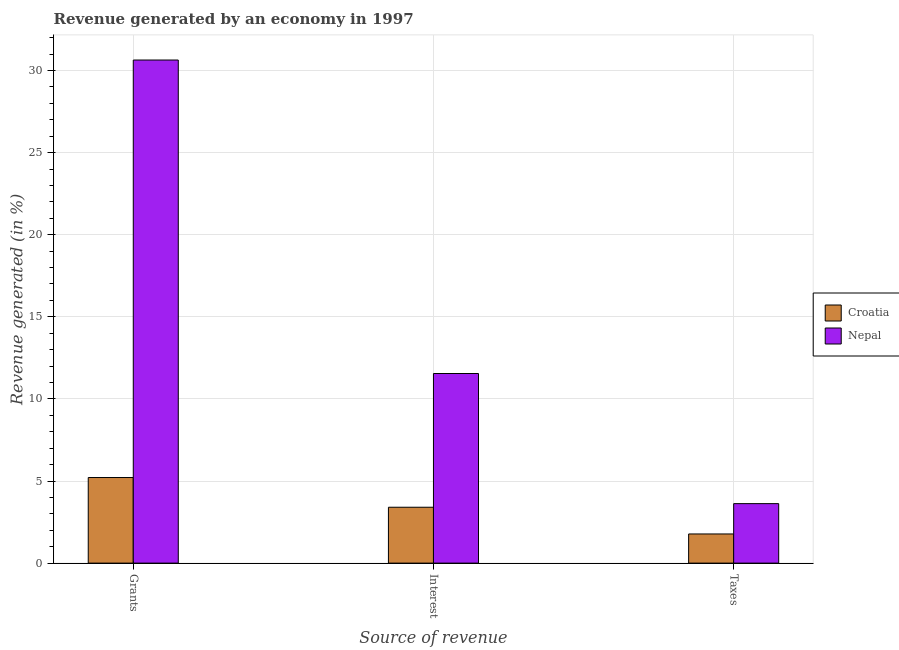How many different coloured bars are there?
Your answer should be very brief. 2. Are the number of bars per tick equal to the number of legend labels?
Ensure brevity in your answer.  Yes. How many bars are there on the 2nd tick from the left?
Provide a short and direct response. 2. How many bars are there on the 2nd tick from the right?
Provide a succinct answer. 2. What is the label of the 1st group of bars from the left?
Make the answer very short. Grants. What is the percentage of revenue generated by interest in Croatia?
Ensure brevity in your answer.  3.4. Across all countries, what is the maximum percentage of revenue generated by taxes?
Make the answer very short. 3.62. Across all countries, what is the minimum percentage of revenue generated by interest?
Offer a very short reply. 3.4. In which country was the percentage of revenue generated by taxes maximum?
Your answer should be compact. Nepal. In which country was the percentage of revenue generated by grants minimum?
Your response must be concise. Croatia. What is the total percentage of revenue generated by grants in the graph?
Ensure brevity in your answer.  35.85. What is the difference between the percentage of revenue generated by grants in Croatia and that in Nepal?
Keep it short and to the point. -25.43. What is the difference between the percentage of revenue generated by grants in Croatia and the percentage of revenue generated by taxes in Nepal?
Provide a succinct answer. 1.59. What is the average percentage of revenue generated by interest per country?
Ensure brevity in your answer.  7.48. What is the difference between the percentage of revenue generated by interest and percentage of revenue generated by grants in Croatia?
Offer a terse response. -1.81. In how many countries, is the percentage of revenue generated by grants greater than 3 %?
Your response must be concise. 2. What is the ratio of the percentage of revenue generated by taxes in Croatia to that in Nepal?
Keep it short and to the point. 0.49. What is the difference between the highest and the second highest percentage of revenue generated by interest?
Offer a very short reply. 8.14. What is the difference between the highest and the lowest percentage of revenue generated by interest?
Give a very brief answer. 8.14. In how many countries, is the percentage of revenue generated by interest greater than the average percentage of revenue generated by interest taken over all countries?
Provide a succinct answer. 1. Is the sum of the percentage of revenue generated by grants in Nepal and Croatia greater than the maximum percentage of revenue generated by taxes across all countries?
Keep it short and to the point. Yes. What does the 2nd bar from the left in Interest represents?
Your answer should be compact. Nepal. What does the 2nd bar from the right in Taxes represents?
Your answer should be very brief. Croatia. How many bars are there?
Make the answer very short. 6. How many countries are there in the graph?
Offer a terse response. 2. Does the graph contain any zero values?
Your answer should be compact. No. Does the graph contain grids?
Provide a short and direct response. Yes. Where does the legend appear in the graph?
Provide a short and direct response. Center right. What is the title of the graph?
Offer a very short reply. Revenue generated by an economy in 1997. What is the label or title of the X-axis?
Your answer should be compact. Source of revenue. What is the label or title of the Y-axis?
Provide a short and direct response. Revenue generated (in %). What is the Revenue generated (in %) of Croatia in Grants?
Your answer should be very brief. 5.21. What is the Revenue generated (in %) of Nepal in Grants?
Your response must be concise. 30.64. What is the Revenue generated (in %) in Croatia in Interest?
Your answer should be compact. 3.4. What is the Revenue generated (in %) of Nepal in Interest?
Provide a succinct answer. 11.55. What is the Revenue generated (in %) in Croatia in Taxes?
Give a very brief answer. 1.78. What is the Revenue generated (in %) in Nepal in Taxes?
Make the answer very short. 3.62. Across all Source of revenue, what is the maximum Revenue generated (in %) in Croatia?
Give a very brief answer. 5.21. Across all Source of revenue, what is the maximum Revenue generated (in %) in Nepal?
Your answer should be very brief. 30.64. Across all Source of revenue, what is the minimum Revenue generated (in %) in Croatia?
Your answer should be very brief. 1.78. Across all Source of revenue, what is the minimum Revenue generated (in %) in Nepal?
Ensure brevity in your answer.  3.62. What is the total Revenue generated (in %) of Croatia in the graph?
Offer a terse response. 10.39. What is the total Revenue generated (in %) of Nepal in the graph?
Make the answer very short. 45.81. What is the difference between the Revenue generated (in %) in Croatia in Grants and that in Interest?
Make the answer very short. 1.81. What is the difference between the Revenue generated (in %) in Nepal in Grants and that in Interest?
Your answer should be very brief. 19.09. What is the difference between the Revenue generated (in %) in Croatia in Grants and that in Taxes?
Offer a terse response. 3.44. What is the difference between the Revenue generated (in %) in Nepal in Grants and that in Taxes?
Your response must be concise. 27.02. What is the difference between the Revenue generated (in %) in Croatia in Interest and that in Taxes?
Ensure brevity in your answer.  1.63. What is the difference between the Revenue generated (in %) in Nepal in Interest and that in Taxes?
Your answer should be compact. 7.92. What is the difference between the Revenue generated (in %) of Croatia in Grants and the Revenue generated (in %) of Nepal in Interest?
Make the answer very short. -6.33. What is the difference between the Revenue generated (in %) of Croatia in Grants and the Revenue generated (in %) of Nepal in Taxes?
Make the answer very short. 1.59. What is the difference between the Revenue generated (in %) of Croatia in Interest and the Revenue generated (in %) of Nepal in Taxes?
Ensure brevity in your answer.  -0.22. What is the average Revenue generated (in %) of Croatia per Source of revenue?
Provide a short and direct response. 3.46. What is the average Revenue generated (in %) in Nepal per Source of revenue?
Offer a very short reply. 15.27. What is the difference between the Revenue generated (in %) in Croatia and Revenue generated (in %) in Nepal in Grants?
Give a very brief answer. -25.43. What is the difference between the Revenue generated (in %) of Croatia and Revenue generated (in %) of Nepal in Interest?
Ensure brevity in your answer.  -8.14. What is the difference between the Revenue generated (in %) in Croatia and Revenue generated (in %) in Nepal in Taxes?
Make the answer very short. -1.85. What is the ratio of the Revenue generated (in %) in Croatia in Grants to that in Interest?
Offer a very short reply. 1.53. What is the ratio of the Revenue generated (in %) of Nepal in Grants to that in Interest?
Provide a succinct answer. 2.65. What is the ratio of the Revenue generated (in %) of Croatia in Grants to that in Taxes?
Your response must be concise. 2.94. What is the ratio of the Revenue generated (in %) in Nepal in Grants to that in Taxes?
Your response must be concise. 8.46. What is the ratio of the Revenue generated (in %) of Croatia in Interest to that in Taxes?
Offer a very short reply. 1.92. What is the ratio of the Revenue generated (in %) in Nepal in Interest to that in Taxes?
Give a very brief answer. 3.19. What is the difference between the highest and the second highest Revenue generated (in %) of Croatia?
Your response must be concise. 1.81. What is the difference between the highest and the second highest Revenue generated (in %) of Nepal?
Ensure brevity in your answer.  19.09. What is the difference between the highest and the lowest Revenue generated (in %) of Croatia?
Provide a succinct answer. 3.44. What is the difference between the highest and the lowest Revenue generated (in %) in Nepal?
Ensure brevity in your answer.  27.02. 